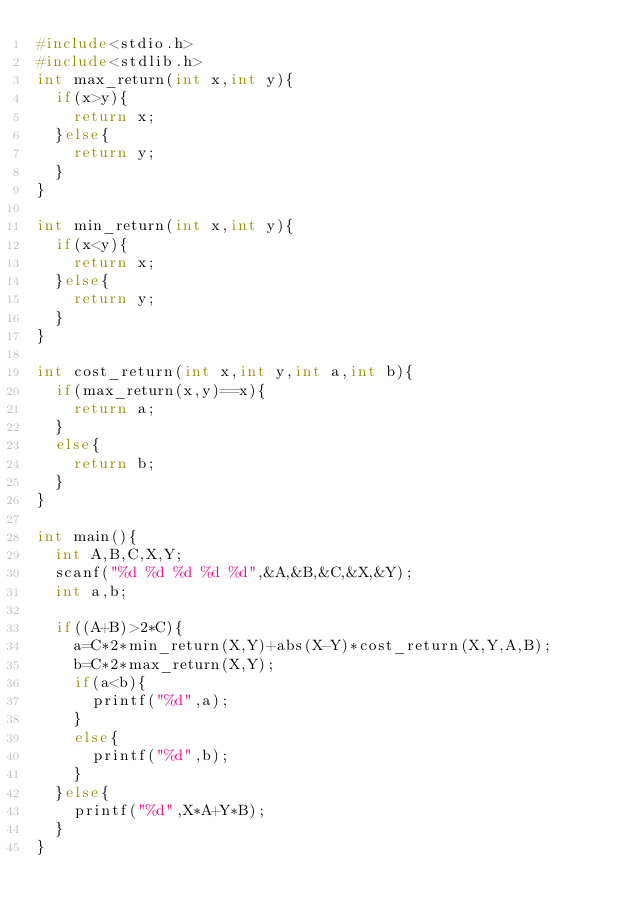Convert code to text. <code><loc_0><loc_0><loc_500><loc_500><_C_>#include<stdio.h>
#include<stdlib.h>
int max_return(int x,int y){
  if(x>y){
    return x;
  }else{
    return y;
  }
}

int min_return(int x,int y){
  if(x<y){
    return x;
  }else{
    return y;
  }
}

int cost_return(int x,int y,int a,int b){
  if(max_return(x,y)==x){
    return a;
  }
  else{
    return b;
  }
}

int main(){
  int A,B,C,X,Y;
  scanf("%d %d %d %d %d",&A,&B,&C,&X,&Y);
  int a,b;

  if((A+B)>2*C){
    a=C*2*min_return(X,Y)+abs(X-Y)*cost_return(X,Y,A,B);
    b=C*2*max_return(X,Y);
    if(a<b){
      printf("%d",a);
    }
    else{
      printf("%d",b);
    }
  }else{
    printf("%d",X*A+Y*B);
  }
}

</code> 